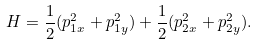<formula> <loc_0><loc_0><loc_500><loc_500>H = \frac { 1 } { 2 } ( p _ { 1 x } ^ { 2 } + p _ { 1 y } ^ { 2 } ) + \frac { 1 } { 2 } ( p _ { 2 x } ^ { 2 } + p _ { 2 y } ^ { 2 } ) .</formula> 